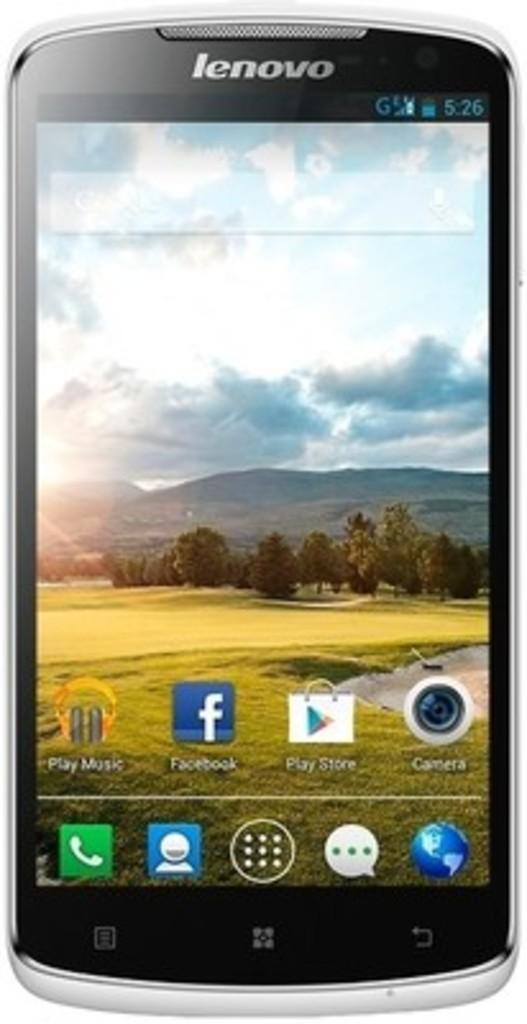<image>
Describe the image concisely. A Lenovo smart phonehas a Play Music icon, Facebook, Play Store and others on the screen. 